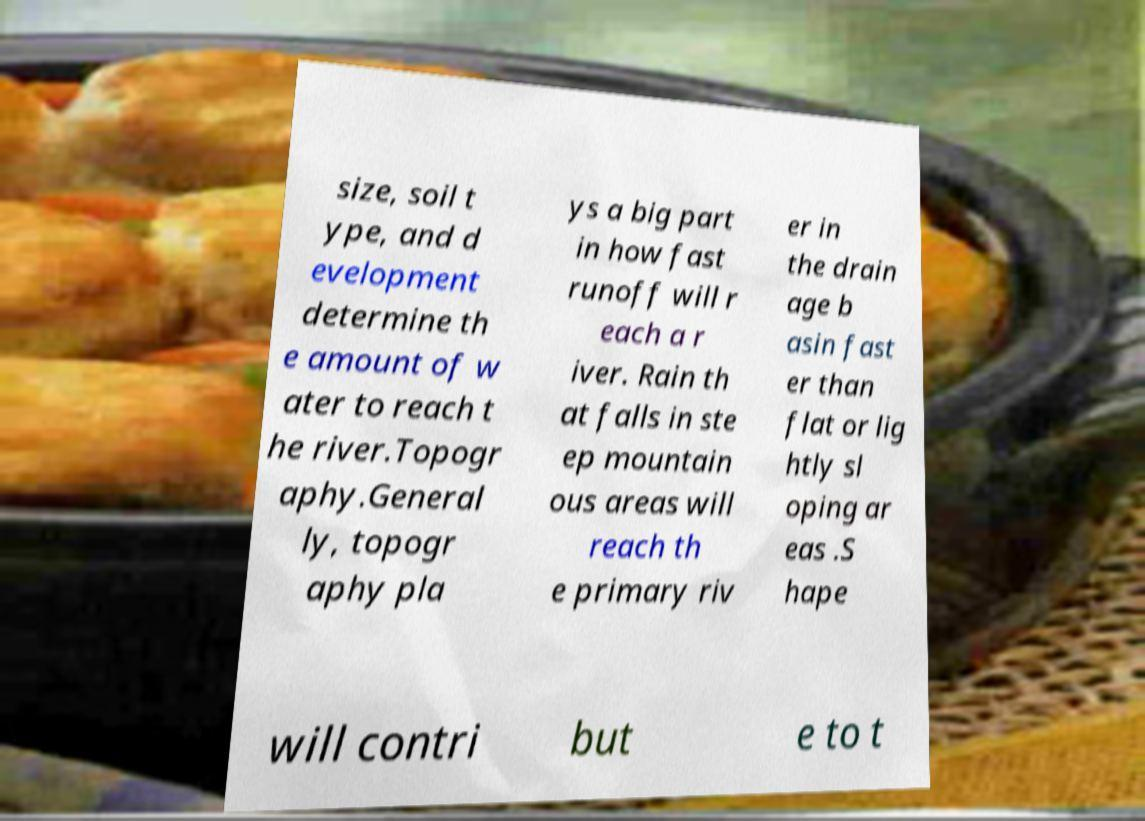Can you accurately transcribe the text from the provided image for me? size, soil t ype, and d evelopment determine th e amount of w ater to reach t he river.Topogr aphy.General ly, topogr aphy pla ys a big part in how fast runoff will r each a r iver. Rain th at falls in ste ep mountain ous areas will reach th e primary riv er in the drain age b asin fast er than flat or lig htly sl oping ar eas .S hape will contri but e to t 